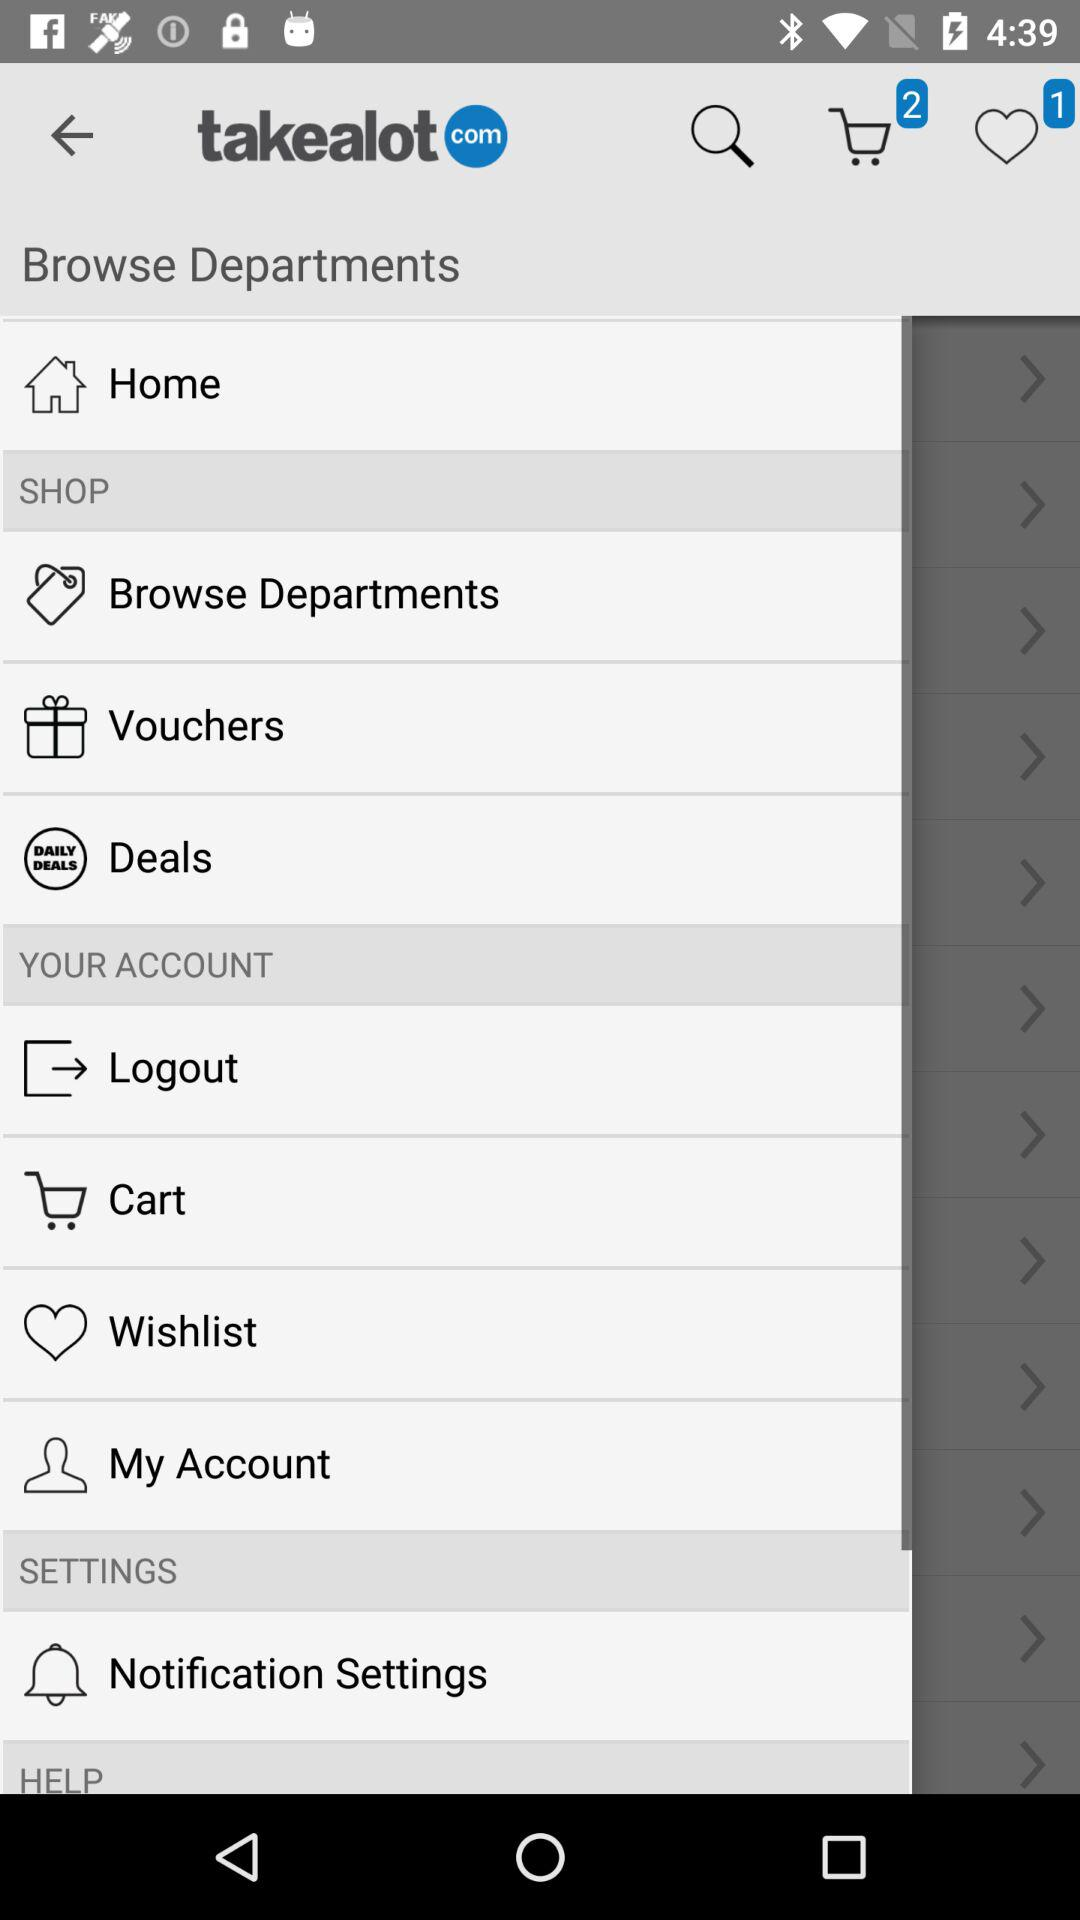How many items are added to the cart? The number of items that are added to the cart is 2. 